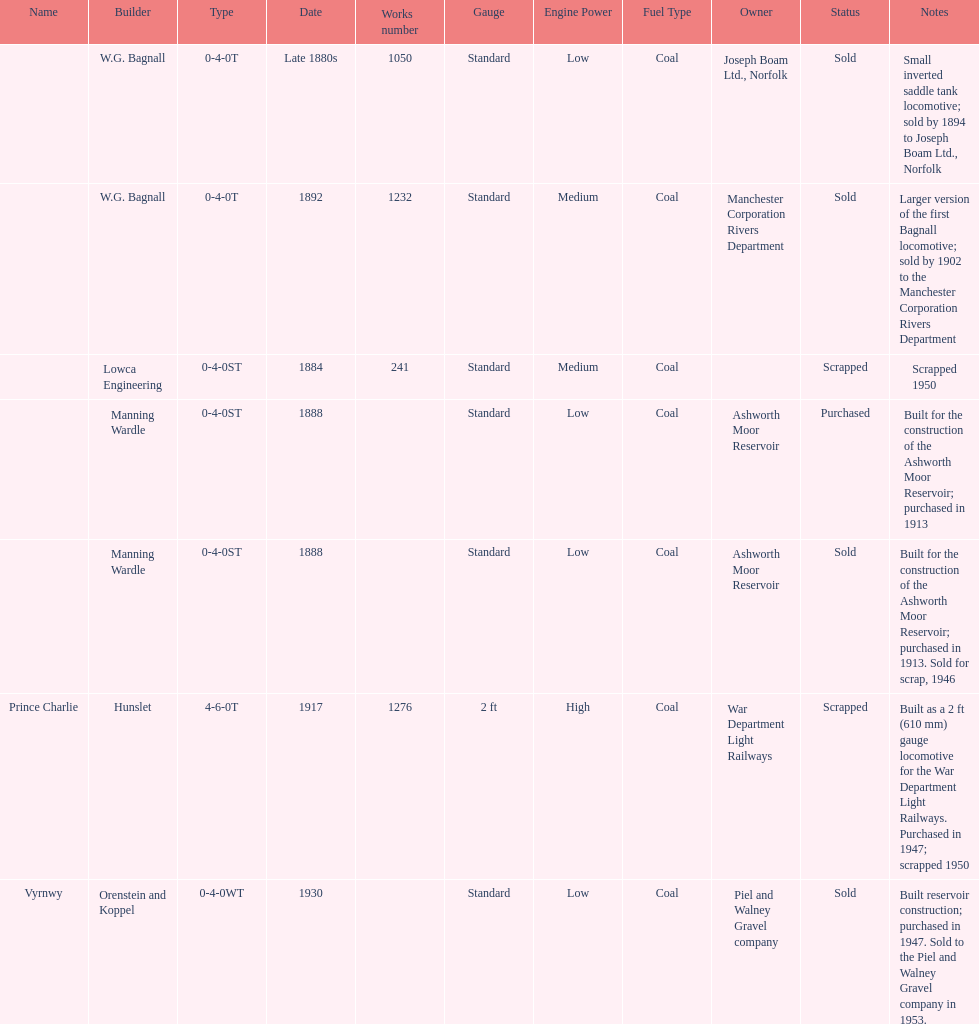How many locomotives were built after 1900? 2. 